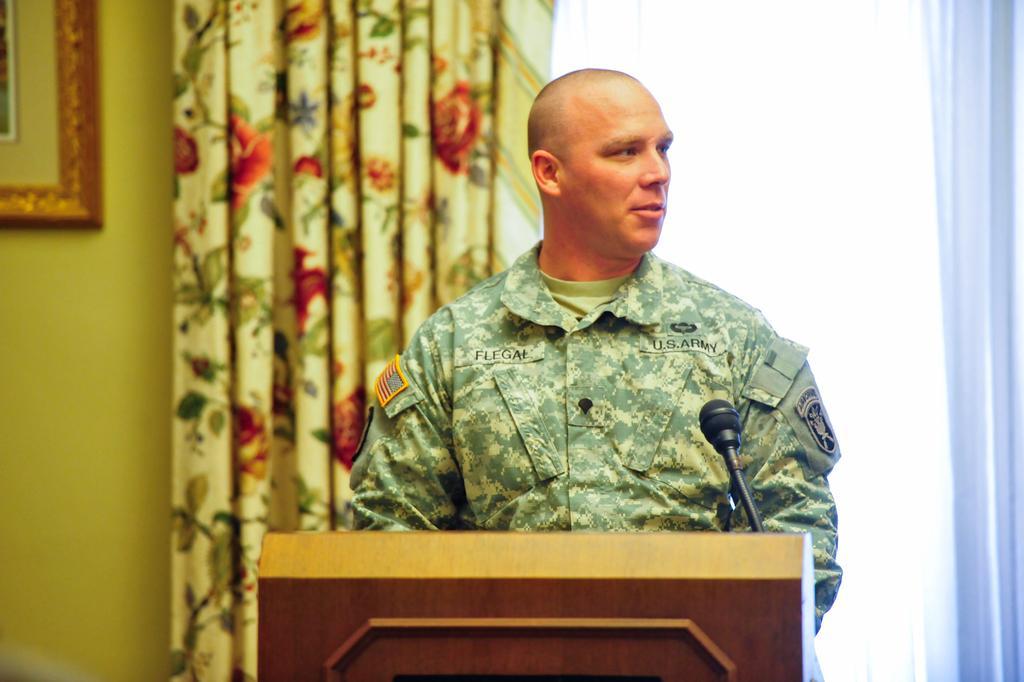How would you summarize this image in a sentence or two? In the foreground of this image, there is a man standing in front of a podium on which there is a mike. In the background, there is a curtain and it seems like a frame on the wall on the left. On the right, it seems like a window. 